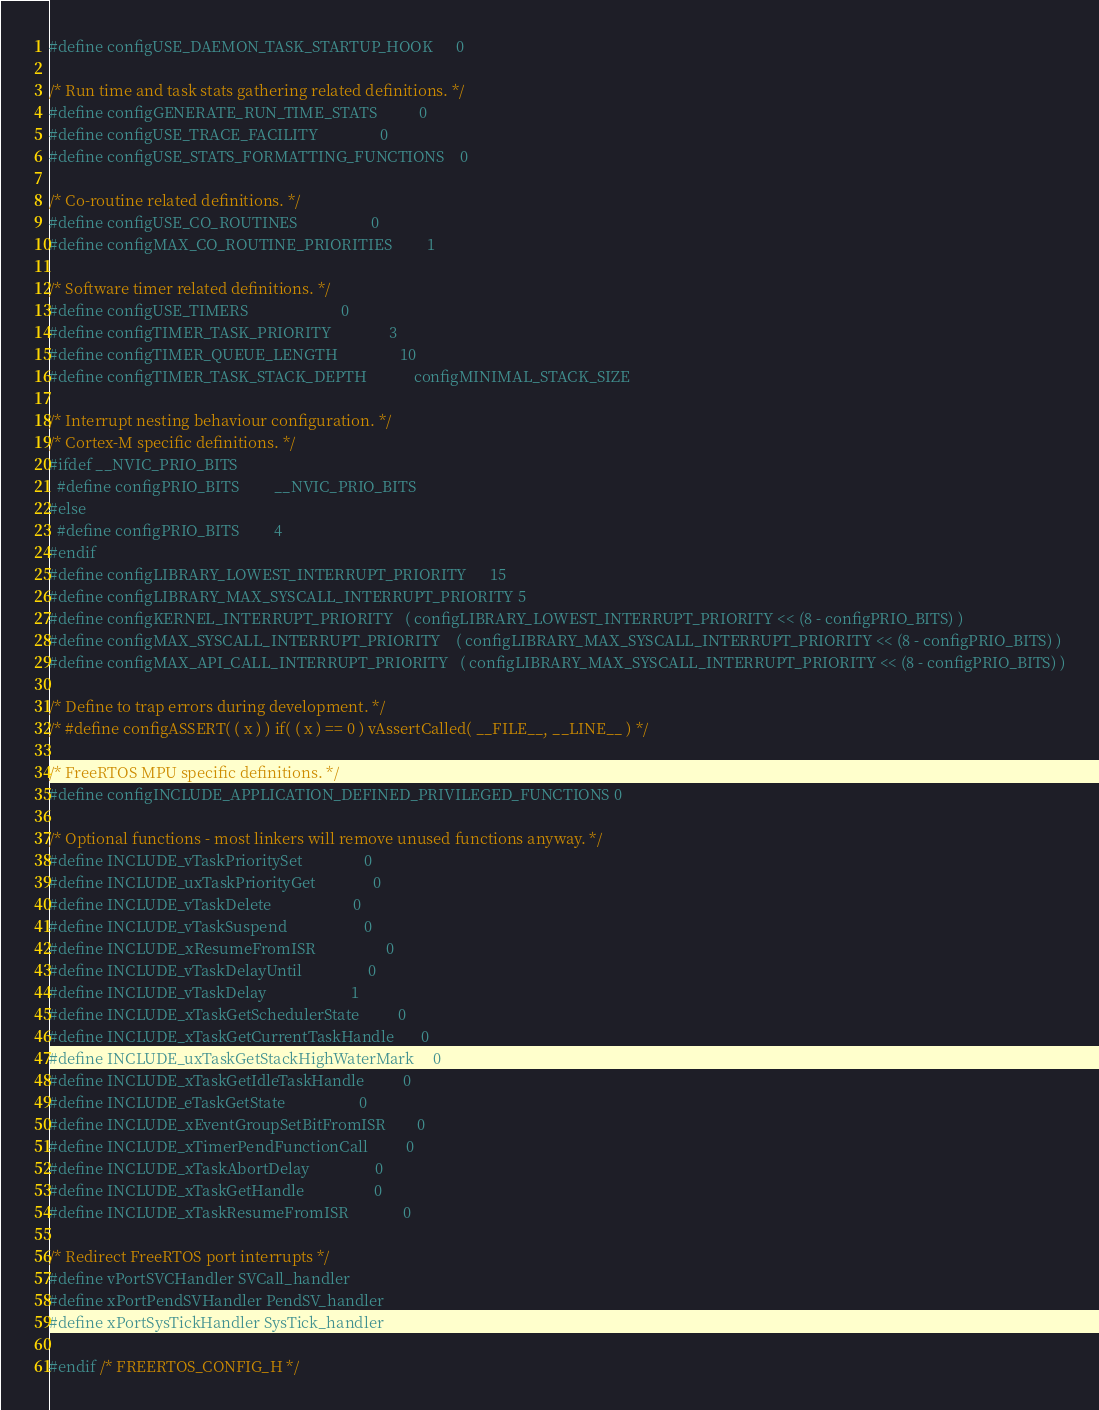<code> <loc_0><loc_0><loc_500><loc_500><_C_>#define configUSE_DAEMON_TASK_STARTUP_HOOK      0

/* Run time and task stats gathering related definitions. */
#define configGENERATE_RUN_TIME_STATS           0
#define configUSE_TRACE_FACILITY                0
#define configUSE_STATS_FORMATTING_FUNCTIONS    0

/* Co-routine related definitions. */
#define configUSE_CO_ROUTINES                   0
#define configMAX_CO_ROUTINE_PRIORITIES         1

/* Software timer related definitions. */
#define configUSE_TIMERS                        0
#define configTIMER_TASK_PRIORITY               3
#define configTIMER_QUEUE_LENGTH                10
#define configTIMER_TASK_STACK_DEPTH            configMINIMAL_STACK_SIZE

/* Interrupt nesting behaviour configuration. */
/* Cortex-M specific definitions. */
#ifdef __NVIC_PRIO_BITS
  #define configPRIO_BITS         __NVIC_PRIO_BITS
#else
  #define configPRIO_BITS         4
#endif
#define configLIBRARY_LOWEST_INTERRUPT_PRIORITY      15
#define configLIBRARY_MAX_SYSCALL_INTERRUPT_PRIORITY 5
#define configKERNEL_INTERRUPT_PRIORITY   ( configLIBRARY_LOWEST_INTERRUPT_PRIORITY << (8 - configPRIO_BITS) )
#define configMAX_SYSCALL_INTERRUPT_PRIORITY    ( configLIBRARY_MAX_SYSCALL_INTERRUPT_PRIORITY << (8 - configPRIO_BITS) )
#define configMAX_API_CALL_INTERRUPT_PRIORITY   ( configLIBRARY_MAX_SYSCALL_INTERRUPT_PRIORITY << (8 - configPRIO_BITS) )

/* Define to trap errors during development. */
/* #define configASSERT( ( x ) ) if( ( x ) == 0 ) vAssertCalled( __FILE__, __LINE__ ) */

/* FreeRTOS MPU specific definitions. */
#define configINCLUDE_APPLICATION_DEFINED_PRIVILEGED_FUNCTIONS 0

/* Optional functions - most linkers will remove unused functions anyway. */
#define INCLUDE_vTaskPrioritySet                0
#define INCLUDE_uxTaskPriorityGet               0
#define INCLUDE_vTaskDelete                     0
#define INCLUDE_vTaskSuspend                    0
#define INCLUDE_xResumeFromISR                  0
#define INCLUDE_vTaskDelayUntil                 0
#define INCLUDE_vTaskDelay                      1
#define INCLUDE_xTaskGetSchedulerState          0
#define INCLUDE_xTaskGetCurrentTaskHandle       0
#define INCLUDE_uxTaskGetStackHighWaterMark     0
#define INCLUDE_xTaskGetIdleTaskHandle          0
#define INCLUDE_eTaskGetState                   0
#define INCLUDE_xEventGroupSetBitFromISR        0
#define INCLUDE_xTimerPendFunctionCall          0
#define INCLUDE_xTaskAbortDelay                 0
#define INCLUDE_xTaskGetHandle                  0
#define INCLUDE_xTaskResumeFromISR              0

/* Redirect FreeRTOS port interrupts */
#define vPortSVCHandler SVCall_handler
#define xPortPendSVHandler PendSV_handler
#define xPortSysTickHandler SysTick_handler

#endif /* FREERTOS_CONFIG_H */
</code> 